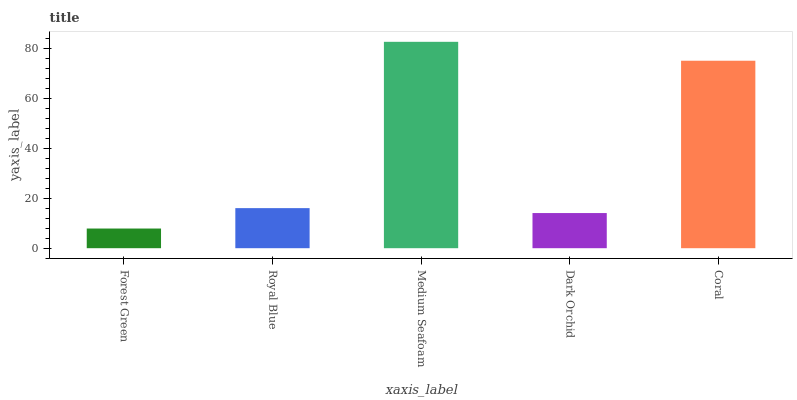Is Forest Green the minimum?
Answer yes or no. Yes. Is Medium Seafoam the maximum?
Answer yes or no. Yes. Is Royal Blue the minimum?
Answer yes or no. No. Is Royal Blue the maximum?
Answer yes or no. No. Is Royal Blue greater than Forest Green?
Answer yes or no. Yes. Is Forest Green less than Royal Blue?
Answer yes or no. Yes. Is Forest Green greater than Royal Blue?
Answer yes or no. No. Is Royal Blue less than Forest Green?
Answer yes or no. No. Is Royal Blue the high median?
Answer yes or no. Yes. Is Royal Blue the low median?
Answer yes or no. Yes. Is Dark Orchid the high median?
Answer yes or no. No. Is Dark Orchid the low median?
Answer yes or no. No. 